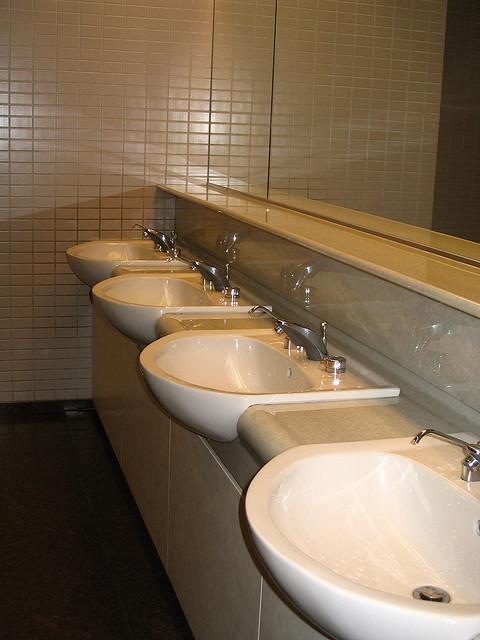What is in reflection?
Answer briefly. Wall. Was this picture taken in someone's home?
Give a very brief answer. No. How many sinks are there?
Answer briefly. 4. 